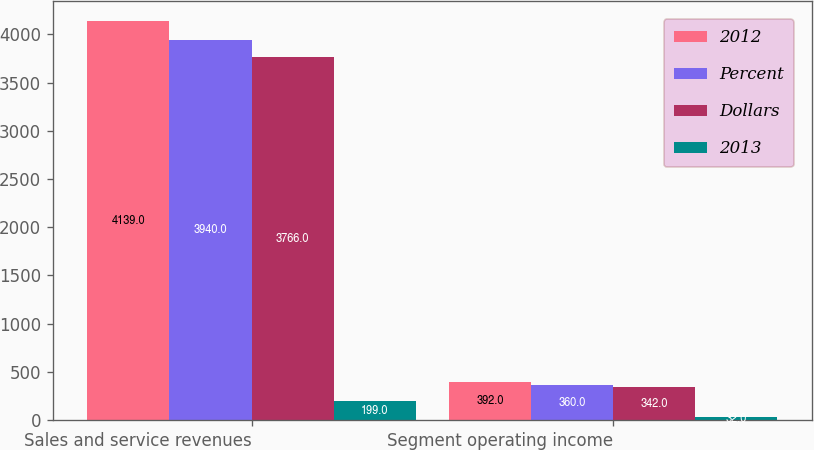Convert chart. <chart><loc_0><loc_0><loc_500><loc_500><stacked_bar_chart><ecel><fcel>Sales and service revenues<fcel>Segment operating income<nl><fcel>2012<fcel>4139<fcel>392<nl><fcel>Percent<fcel>3940<fcel>360<nl><fcel>Dollars<fcel>3766<fcel>342<nl><fcel>2013<fcel>199<fcel>32<nl></chart> 